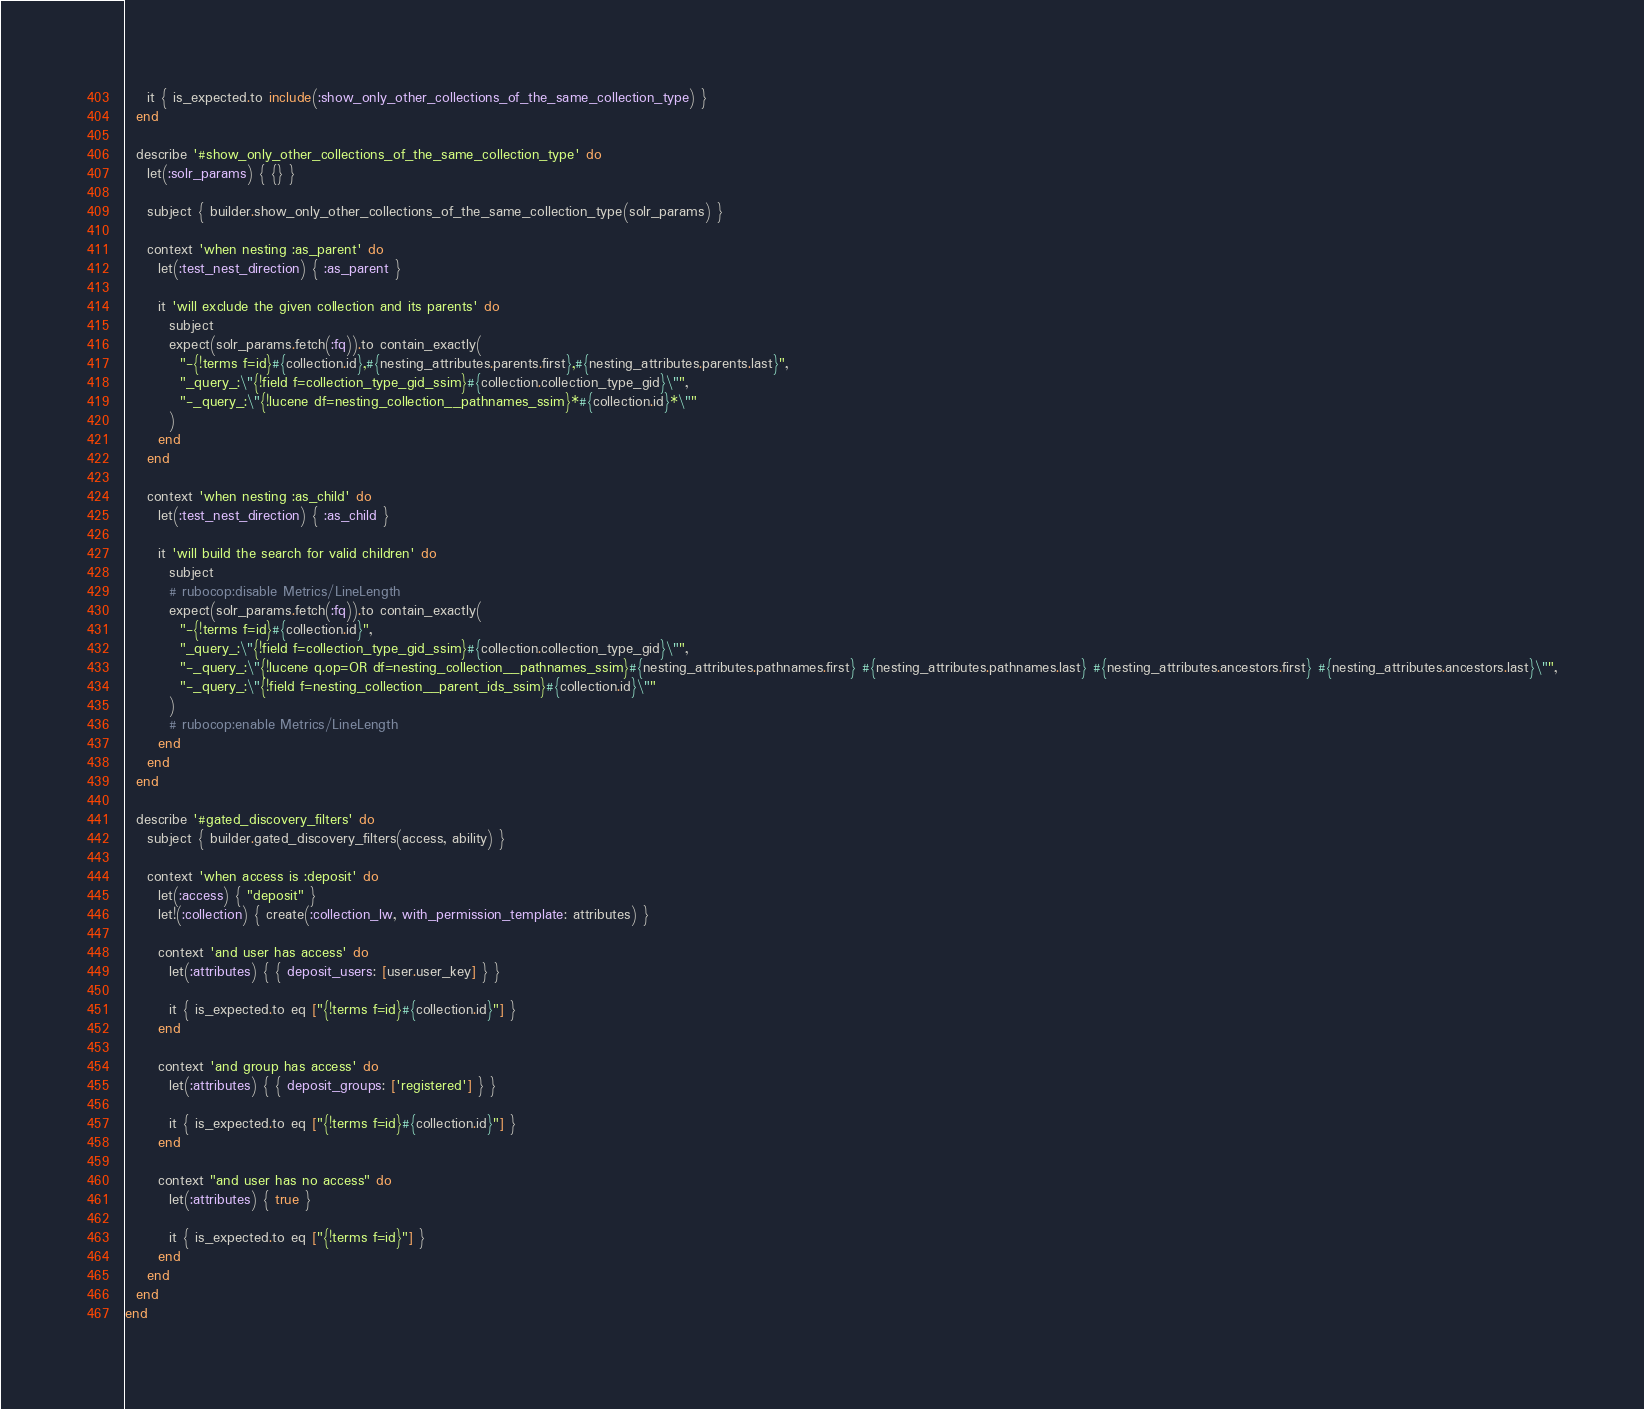Convert code to text. <code><loc_0><loc_0><loc_500><loc_500><_Ruby_>    it { is_expected.to include(:show_only_other_collections_of_the_same_collection_type) }
  end

  describe '#show_only_other_collections_of_the_same_collection_type' do
    let(:solr_params) { {} }

    subject { builder.show_only_other_collections_of_the_same_collection_type(solr_params) }

    context 'when nesting :as_parent' do
      let(:test_nest_direction) { :as_parent }

      it 'will exclude the given collection and its parents' do
        subject
        expect(solr_params.fetch(:fq)).to contain_exactly(
          "-{!terms f=id}#{collection.id},#{nesting_attributes.parents.first},#{nesting_attributes.parents.last}",
          "_query_:\"{!field f=collection_type_gid_ssim}#{collection.collection_type_gid}\"",
          "-_query_:\"{!lucene df=nesting_collection__pathnames_ssim}*#{collection.id}*\""
        )
      end
    end

    context 'when nesting :as_child' do
      let(:test_nest_direction) { :as_child }

      it 'will build the search for valid children' do
        subject
        # rubocop:disable Metrics/LineLength
        expect(solr_params.fetch(:fq)).to contain_exactly(
          "-{!terms f=id}#{collection.id}",
          "_query_:\"{!field f=collection_type_gid_ssim}#{collection.collection_type_gid}\"",
          "-_query_:\"{!lucene q.op=OR df=nesting_collection__pathnames_ssim}#{nesting_attributes.pathnames.first} #{nesting_attributes.pathnames.last} #{nesting_attributes.ancestors.first} #{nesting_attributes.ancestors.last}\"",
          "-_query_:\"{!field f=nesting_collection__parent_ids_ssim}#{collection.id}\""
        )
        # rubocop:enable Metrics/LineLength
      end
    end
  end

  describe '#gated_discovery_filters' do
    subject { builder.gated_discovery_filters(access, ability) }

    context 'when access is :deposit' do
      let(:access) { "deposit" }
      let!(:collection) { create(:collection_lw, with_permission_template: attributes) }

      context 'and user has access' do
        let(:attributes) { { deposit_users: [user.user_key] } }

        it { is_expected.to eq ["{!terms f=id}#{collection.id}"] }
      end

      context 'and group has access' do
        let(:attributes) { { deposit_groups: ['registered'] } }

        it { is_expected.to eq ["{!terms f=id}#{collection.id}"] }
      end

      context "and user has no access" do
        let(:attributes) { true }

        it { is_expected.to eq ["{!terms f=id}"] }
      end
    end
  end
end
</code> 